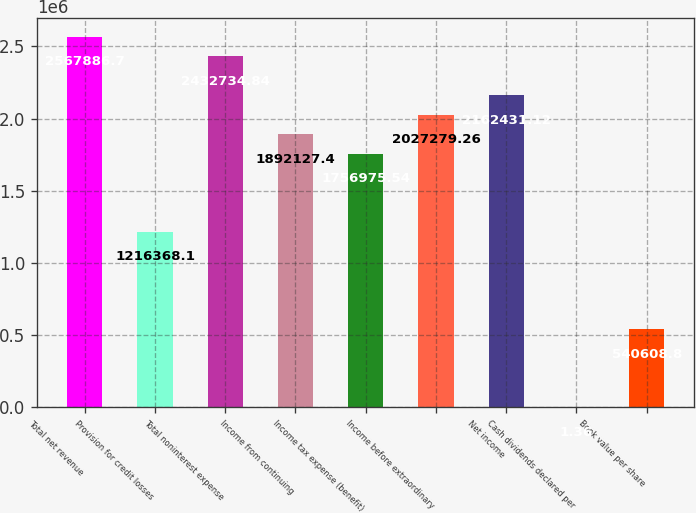Convert chart. <chart><loc_0><loc_0><loc_500><loc_500><bar_chart><fcel>Total net revenue<fcel>Provision for credit losses<fcel>Total noninterest expense<fcel>Income from continuing<fcel>Income tax expense (benefit)<fcel>Income before extraordinary<fcel>Net income<fcel>Cash dividends declared per<fcel>Book value per share<nl><fcel>2.56789e+06<fcel>1.21637e+06<fcel>2.43273e+06<fcel>1.89213e+06<fcel>1.75698e+06<fcel>2.02728e+06<fcel>2.16243e+06<fcel>1.36<fcel>540609<nl></chart> 